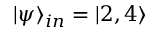Convert formula to latex. <formula><loc_0><loc_0><loc_500><loc_500>| \psi \rangle _ { i n } = | 2 , 4 \rangle</formula> 